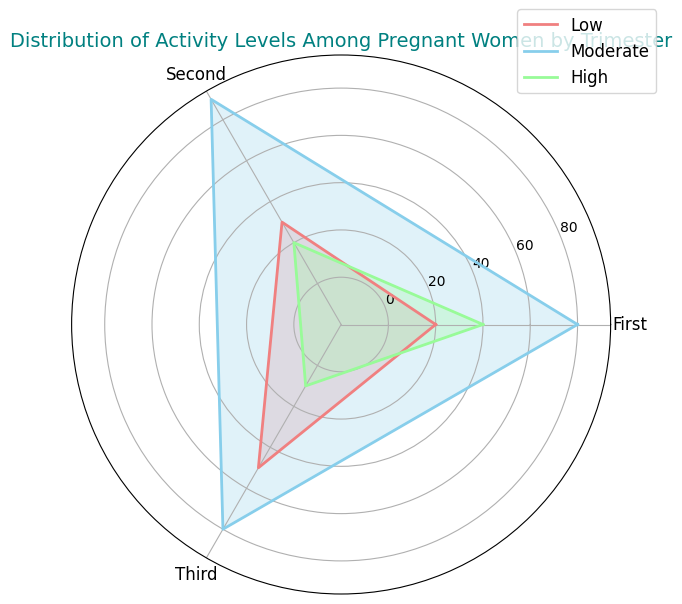What is the most common activity level during the first trimester? By looking at the figure, we see that in the first trimester, the area and height of the "Moderate" section are the largest compared to "Low" and "High", indicating it has the highest percentage.
Answer: Moderate Which trimster has the highest percentage of women with low activity level? By comparing the areas representing "Low" activity level in all three trimesters, the third trimester clearly has the largest section.
Answer: Third Is the proportion of high activity level greater in the first trimester or the second trimester? By comparing the areas and lengths representing "High" activity levels, the first trimester shows a larger section than the second trimester, indicating a greater proportion.
Answer: First What is the combined percentage of moderate activity in the first and second trimesters? The percentage for moderate activity in the first trimester is 50%, and in the second trimester, it is 55%. Adding these together gives 50 + 55 = 105%.
Answer: 105% What trimester has the highest variability in activity levels? Variability can be assessed by looking at the range of the percentages. In the third trimester, the range between "Low" (35%) and "High" (15%) is the largest (35 - 15 = 20%). Other trimesters have smaller ranges of 30% - 20% for the first (30 - 20 = 10%) and 55% - 20% for the second (55 - 20 = 35%).
Answer: Third 